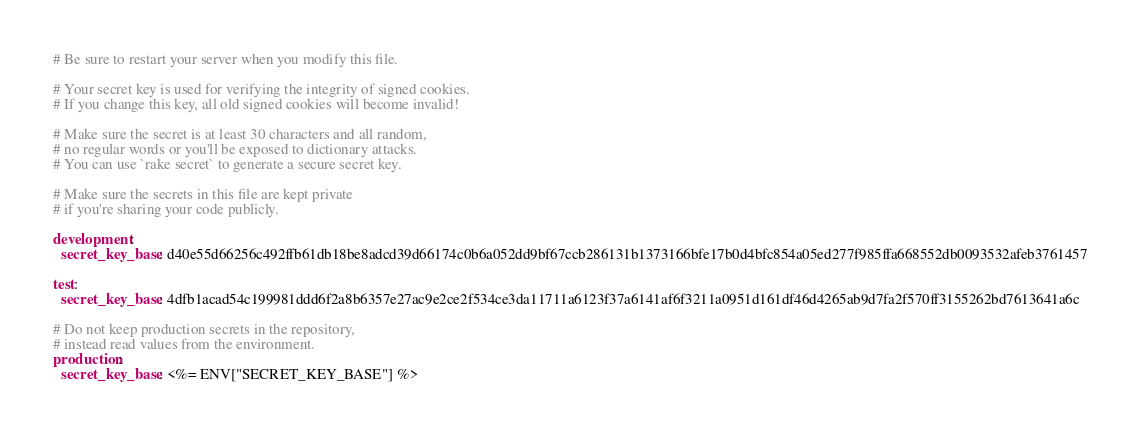<code> <loc_0><loc_0><loc_500><loc_500><_YAML_># Be sure to restart your server when you modify this file.

# Your secret key is used for verifying the integrity of signed cookies.
# If you change this key, all old signed cookies will become invalid!

# Make sure the secret is at least 30 characters and all random,
# no regular words or you'll be exposed to dictionary attacks.
# You can use `rake secret` to generate a secure secret key.

# Make sure the secrets in this file are kept private
# if you're sharing your code publicly.

development:
  secret_key_base: d40e55d66256c492ffb61db18be8adcd39d66174c0b6a052dd9bf67ccb286131b1373166bfe17b0d4bfc854a05ed277f985ffa668552db0093532afeb3761457

test:
  secret_key_base: 4dfb1acad54c199981ddd6f2a8b6357e27ac9e2ce2f534ce3da11711a6123f37a6141af6f3211a0951d161df46d4265ab9d7fa2f570ff3155262bd7613641a6c

# Do not keep production secrets in the repository,
# instead read values from the environment.
production:
  secret_key_base: <%= ENV["SECRET_KEY_BASE"] %>
</code> 